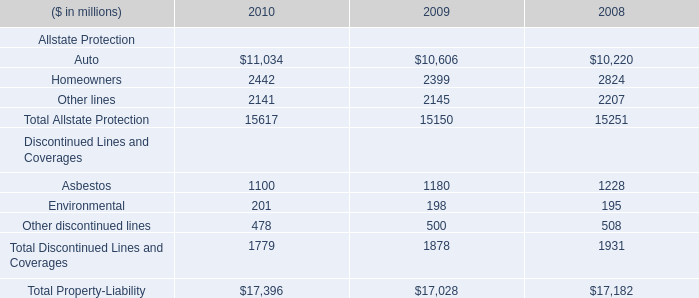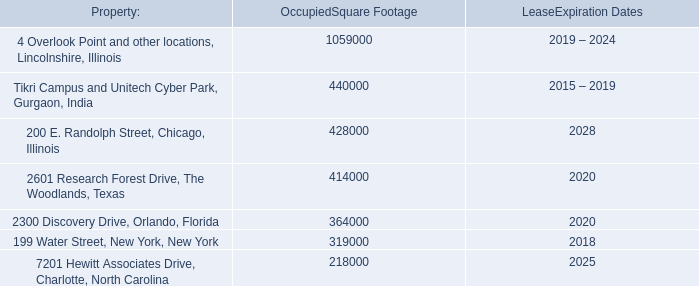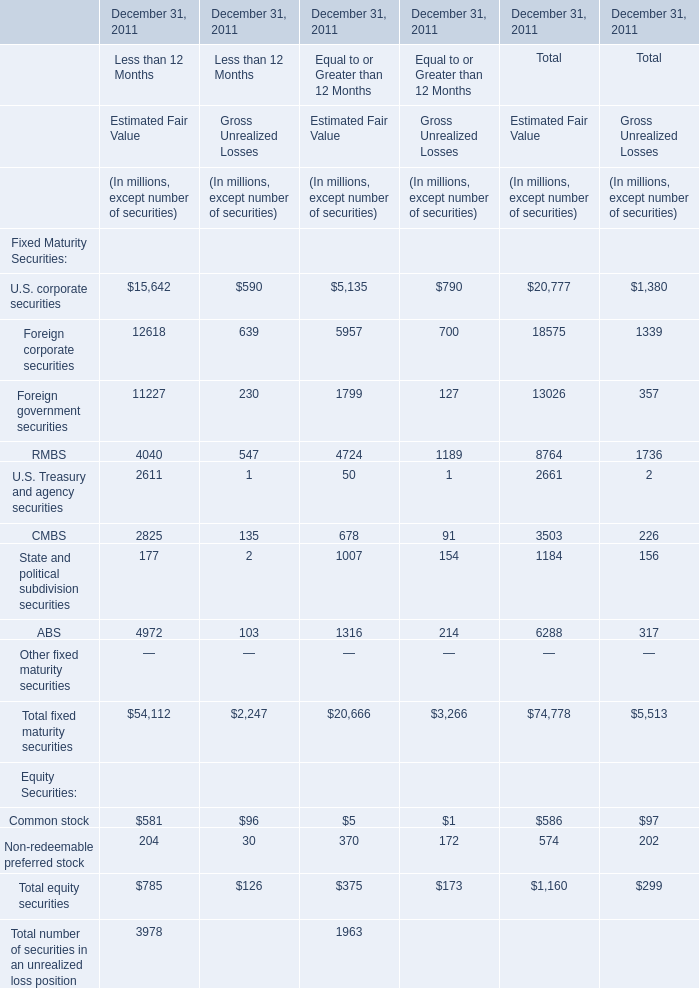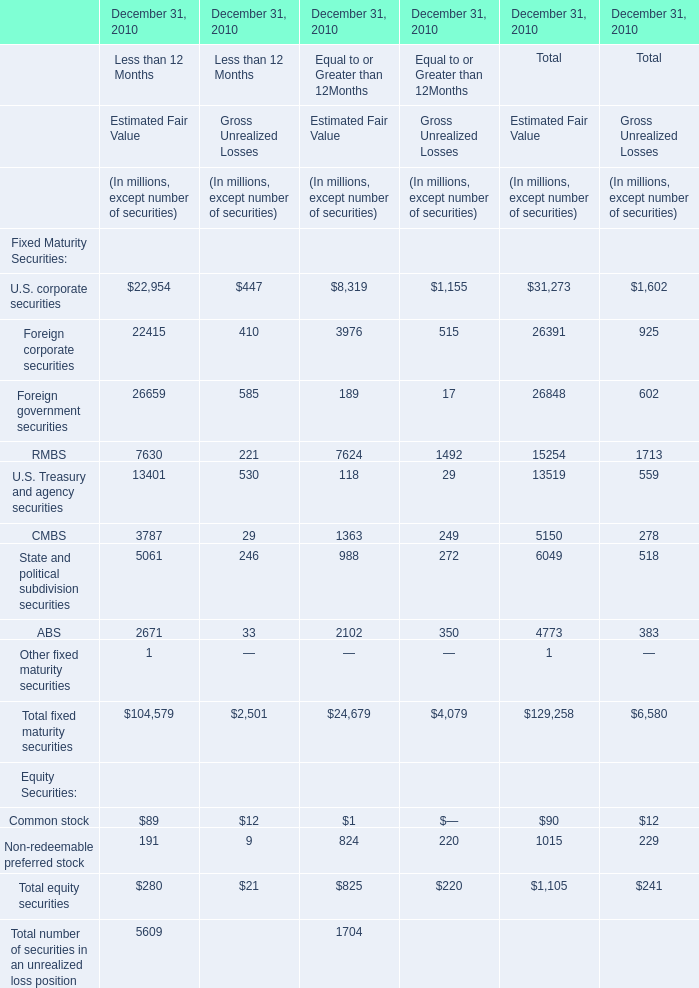What is the sum of Other lines of 2010, and 7201 Hewitt Associates Drive, Charlotte, North Carolina of OccupiedSquare Footage ? 
Computations: (2141.0 + 218000.0)
Answer: 220141.0. 